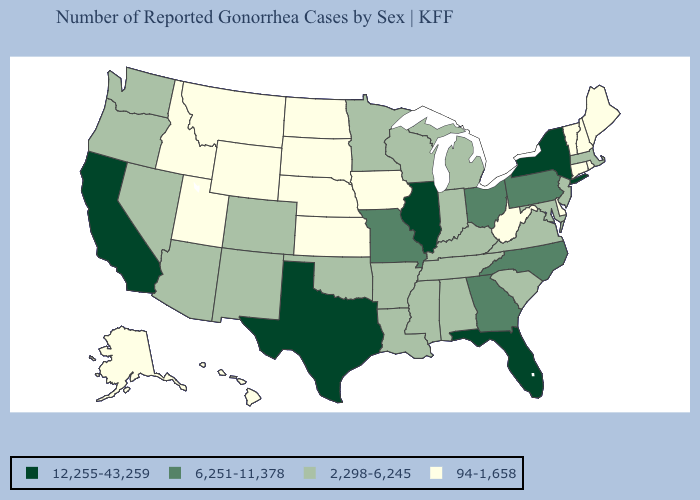What is the lowest value in the USA?
Quick response, please. 94-1,658. What is the highest value in states that border Washington?
Keep it brief. 2,298-6,245. Which states have the lowest value in the USA?
Give a very brief answer. Alaska, Connecticut, Delaware, Hawaii, Idaho, Iowa, Kansas, Maine, Montana, Nebraska, New Hampshire, North Dakota, Rhode Island, South Dakota, Utah, Vermont, West Virginia, Wyoming. How many symbols are there in the legend?
Quick response, please. 4. Among the states that border Florida , which have the lowest value?
Concise answer only. Alabama. How many symbols are there in the legend?
Write a very short answer. 4. Does the first symbol in the legend represent the smallest category?
Short answer required. No. Name the states that have a value in the range 2,298-6,245?
Concise answer only. Alabama, Arizona, Arkansas, Colorado, Indiana, Kentucky, Louisiana, Maryland, Massachusetts, Michigan, Minnesota, Mississippi, Nevada, New Jersey, New Mexico, Oklahoma, Oregon, South Carolina, Tennessee, Virginia, Washington, Wisconsin. What is the value of Delaware?
Concise answer only. 94-1,658. Does New Hampshire have the lowest value in the USA?
Give a very brief answer. Yes. What is the value of Connecticut?
Keep it brief. 94-1,658. Does Maryland have the highest value in the USA?
Answer briefly. No. What is the value of Alaska?
Write a very short answer. 94-1,658. 